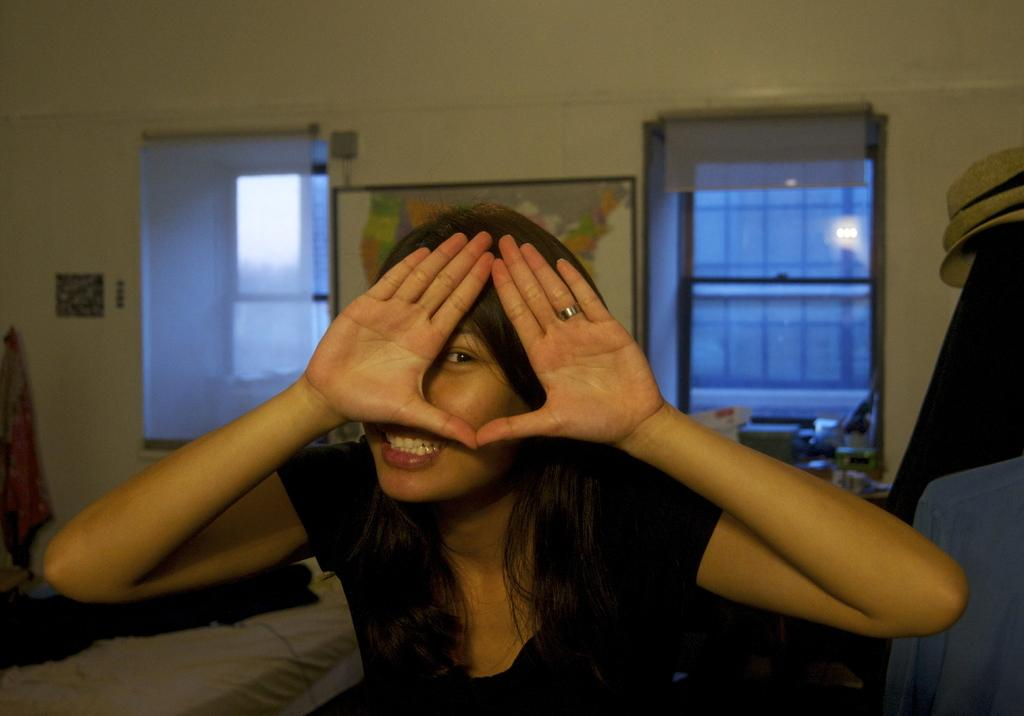Who is present in the image? There is a woman in the image. What is the woman wearing? The woman is wearing clothes and a finger ring. What is the woman's facial expression? The woman is smiling. How many windows are visible in the image? There are two windows visible in the image. What is on the wall in the image? There is a frame and stick on the wall in the image. What type of lipstick is the woman wearing on the stage in the image? There is no stage present in the image, and the woman is not wearing lipstick. 